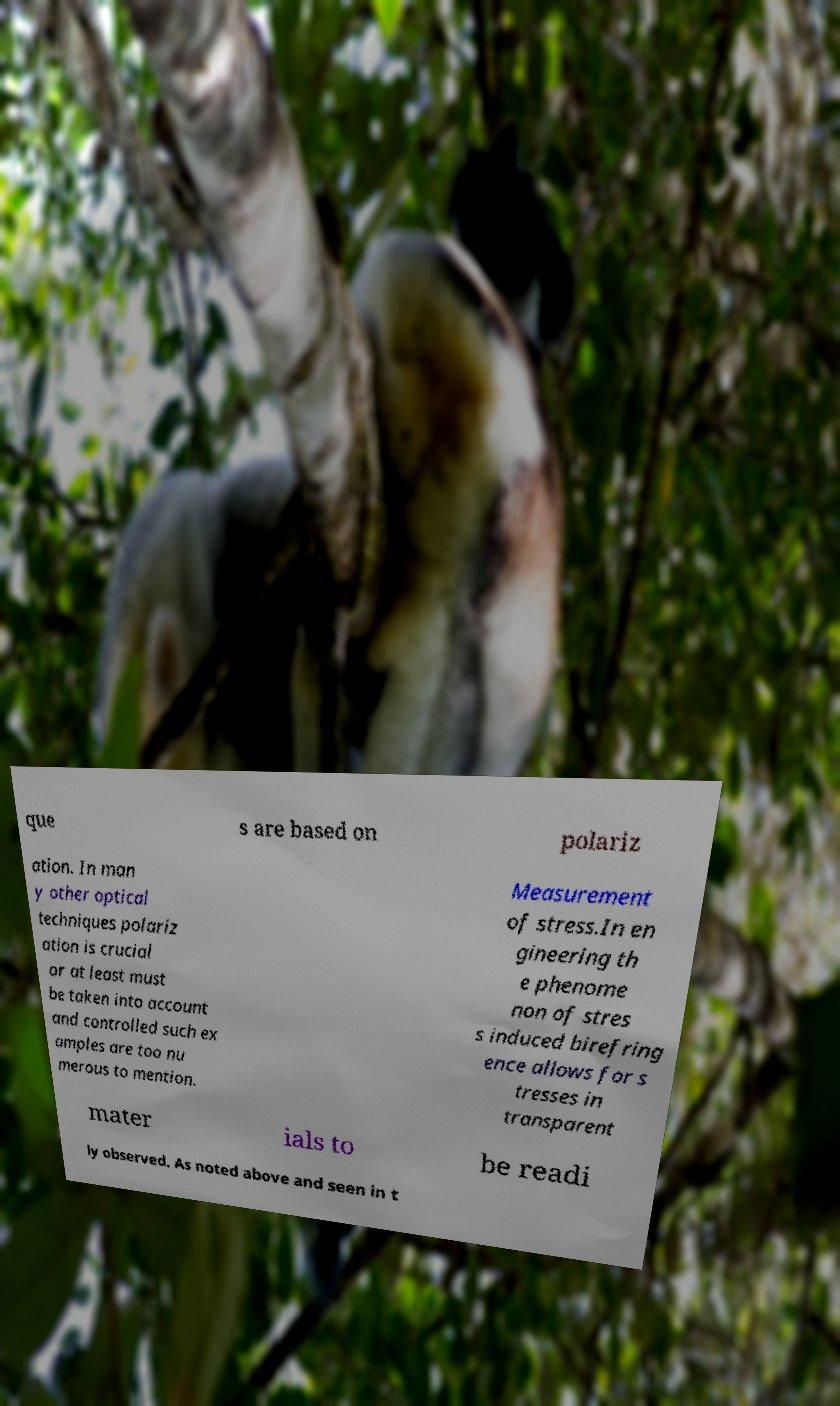What messages or text are displayed in this image? I need them in a readable, typed format. que s are based on polariz ation. In man y other optical techniques polariz ation is crucial or at least must be taken into account and controlled such ex amples are too nu merous to mention. Measurement of stress.In en gineering th e phenome non of stres s induced birefring ence allows for s tresses in transparent mater ials to be readi ly observed. As noted above and seen in t 